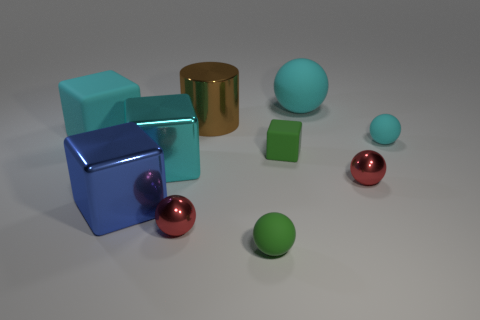Subtract all blue blocks. How many blocks are left? 3 Subtract 1 blocks. How many blocks are left? 3 Subtract all blue cubes. How many cubes are left? 3 Subtract all purple balls. How many red cubes are left? 0 Subtract all metal cylinders. Subtract all big rubber cubes. How many objects are left? 8 Add 2 tiny matte spheres. How many tiny matte spheres are left? 4 Add 6 tiny blue shiny things. How many tiny blue shiny things exist? 6 Subtract 0 brown cubes. How many objects are left? 10 Subtract all cylinders. How many objects are left? 9 Subtract all gray spheres. Subtract all green blocks. How many spheres are left? 5 